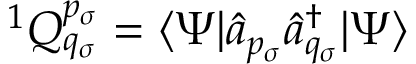<formula> <loc_0><loc_0><loc_500><loc_500>{ } ^ { 1 } Q _ { q _ { \sigma } } ^ { p _ { \sigma } } = \langle \Psi | \hat { a } _ { p _ { \sigma } } \hat { a } _ { q _ { \sigma } } ^ { \dagger } | \Psi \rangle</formula> 